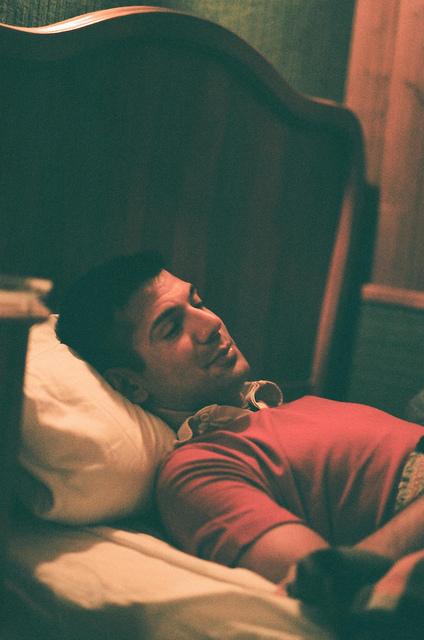Is the headboard made of metal?
Be succinct. No. What is this person laying on?
Answer briefly. Bed. Is this person having a nightmare?
Quick response, please. No. 